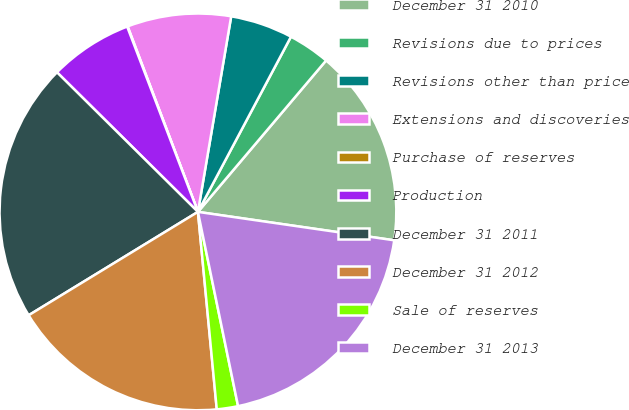Convert chart to OTSL. <chart><loc_0><loc_0><loc_500><loc_500><pie_chart><fcel>December 31 2010<fcel>Revisions due to prices<fcel>Revisions other than price<fcel>Extensions and discoveries<fcel>Purchase of reserves<fcel>Production<fcel>December 31 2011<fcel>December 31 2012<fcel>Sale of reserves<fcel>December 31 2013<nl><fcel>16.11%<fcel>3.41%<fcel>5.09%<fcel>8.45%<fcel>0.04%<fcel>6.77%<fcel>21.15%<fcel>17.79%<fcel>1.73%<fcel>19.47%<nl></chart> 